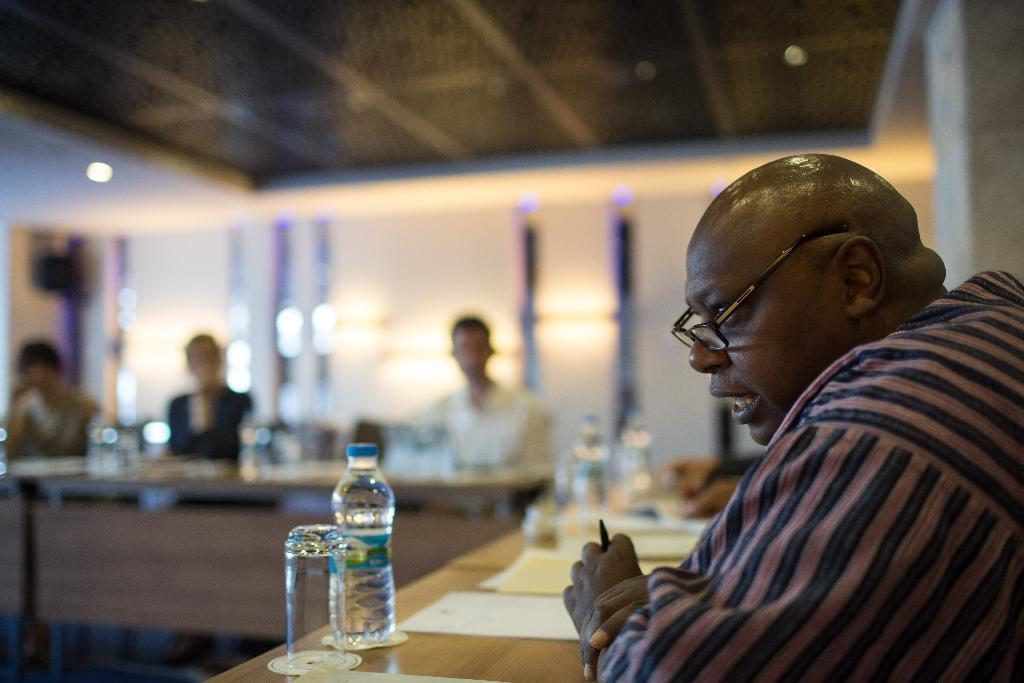How many men are in the image? There are four men in the image. What are the men doing in the image? The men are sitting on chairs. What objects can be seen on the table in the image? There are bottles, glasses, and papers on the table. What can be seen in the background of the image? There is a wall and a light in the background of the image. What direction are the men walking in the image? The men are not walking in the image; they are sitting on chairs. What type of street can be seen in the image? There is no street present in the image. 